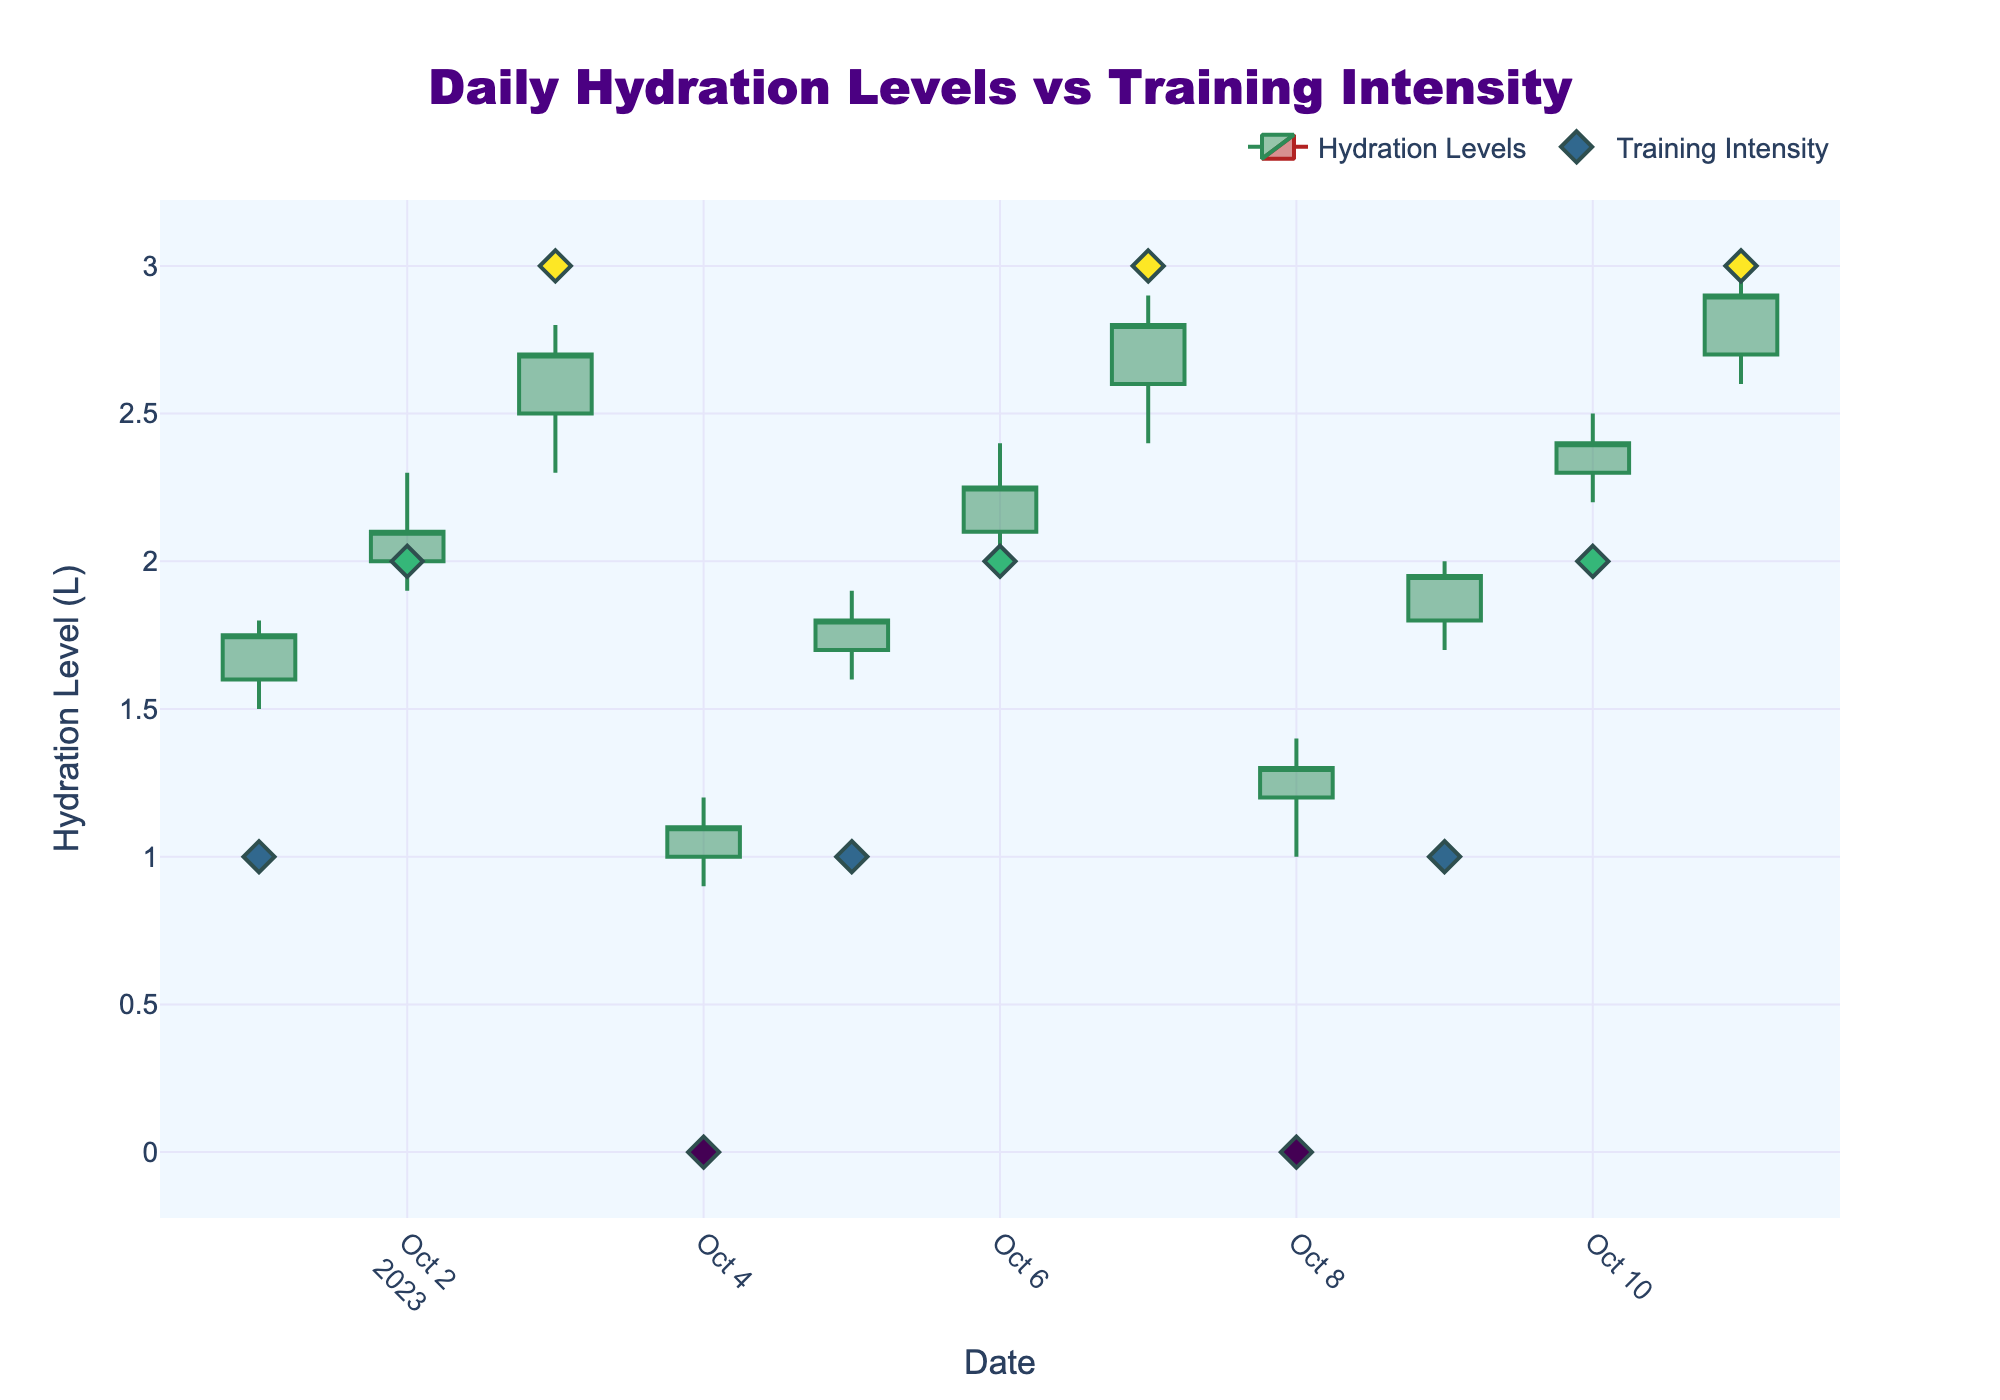When was the highest hydration level recorded, and what was it? The figure shows daily hydration levels where the highest value is indicated by the tallest green candlestick. The date corresponding with the highest high value (3.0L) is on 2023-10-11 during high-intensity training.
Answer: 2023-10-11, 3.0L On which days did the hydration levels not increase throughout the day? Decreasing candlesticks indicate days where the closing hydration level was lower than the opening hydration level. These candlesticks are red. By observing the red candlesticks, you can identify 2023-10-04 and 2023-10-08.
Answer: 2023-10-04, 2023-10-08 Which day had the highest training intensity, and how did the hydration level open and close on that day? By looking at the Training Intensity plot, days with the highest intensity are marked at the top of the Intensity axis. On 2023-10-07, the training intensity was high (3), and the candlestick indicates that the hydration level opened at 2.6L and closed at 2.8L.
Answer: 2023-10-07, Open: 2.6L, Close: 2.8L How many days had their lowest hydration levels at or below 1.0L? Identify the days where the low point of the candlestick touches or goes below the 1.0L line. These days are 2023-10-04 and 2023-10-08.
Answer: 2 days What was the average closing hydration level on low-intensity training days? The closing values on Low training intensity days are 1.75L, 1.8L, and 1.95L. Adding these values, (1.75 + 1.8 + 1.95) = 5.5. The average is 5.5/3 = 1.833.
Answer: 1.83L What was the difference in closing hydration levels between the highest and lowest training intensities on 2023-10-03 and 2023-10-04? On 2023-10-03, the training intensity was high with a closing level of 2.7L. On 2023-10-04, the intensity was rest with a closing level of 1.1L. The difference is 2.7 - 1.1 = 1.6.
Answer: 1.6L Which type of training day saw the most consistent (least volatility) hydration levels throughout the day? Consistency or least volatility is indicated by candlesticks with the smallest range (from low to high values). Visually, the day with Rest intensity (2023-10-04 and 2023-10-08) shows the smallest range.
Answer: Rest What's the highest closing hydration level recorded during moderate training, and on which date did it occur? The highest closing value during moderate training is indicated by the highest closing point in green candlesticks representing moderate intensity. On 2023-10-10, the highest closing level is 2.4L.
Answer: 2023-10-10, 2.4L 